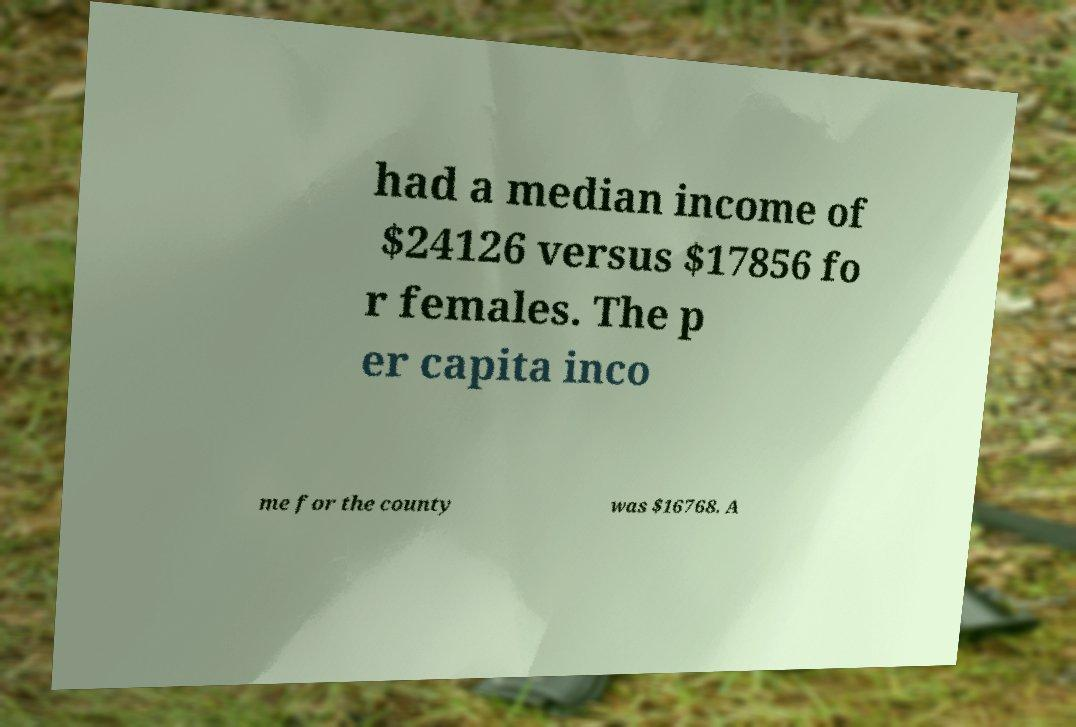Please identify and transcribe the text found in this image. had a median income of $24126 versus $17856 fo r females. The p er capita inco me for the county was $16768. A 